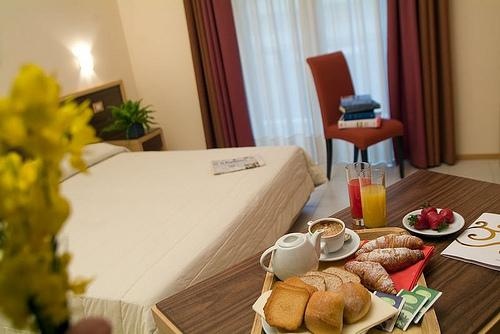Question: what is this?
Choices:
A. A bedroom.
B. A banana tree.
C. A factory.
D. An airport.
Answer with the letter. Answer: A Question: where is room located?
Choices:
A. In a brown house.
B. In a cottage.
C. In a restaurant.
D. In hotel.
Answer with the letter. Answer: D Question: who is in the picture?
Choices:
A. Surfers.
B. Toddlers.
C. No one.
D. Army veterans.
Answer with the letter. Answer: C Question: what is on the table?
Choices:
A. Beer.
B. Snacks.
C. Soda.
D. Wine.
Answer with the letter. Answer: B Question: why are snacks there?
Choices:
A. For a party.
B. For display.
C. For nourishment.
D. For a photo.
Answer with the letter. Answer: C Question: when was picture taken?
Choices:
A. At night.
B. At dawn.
C. During daylight.
D. At dusk.
Answer with the letter. Answer: C 